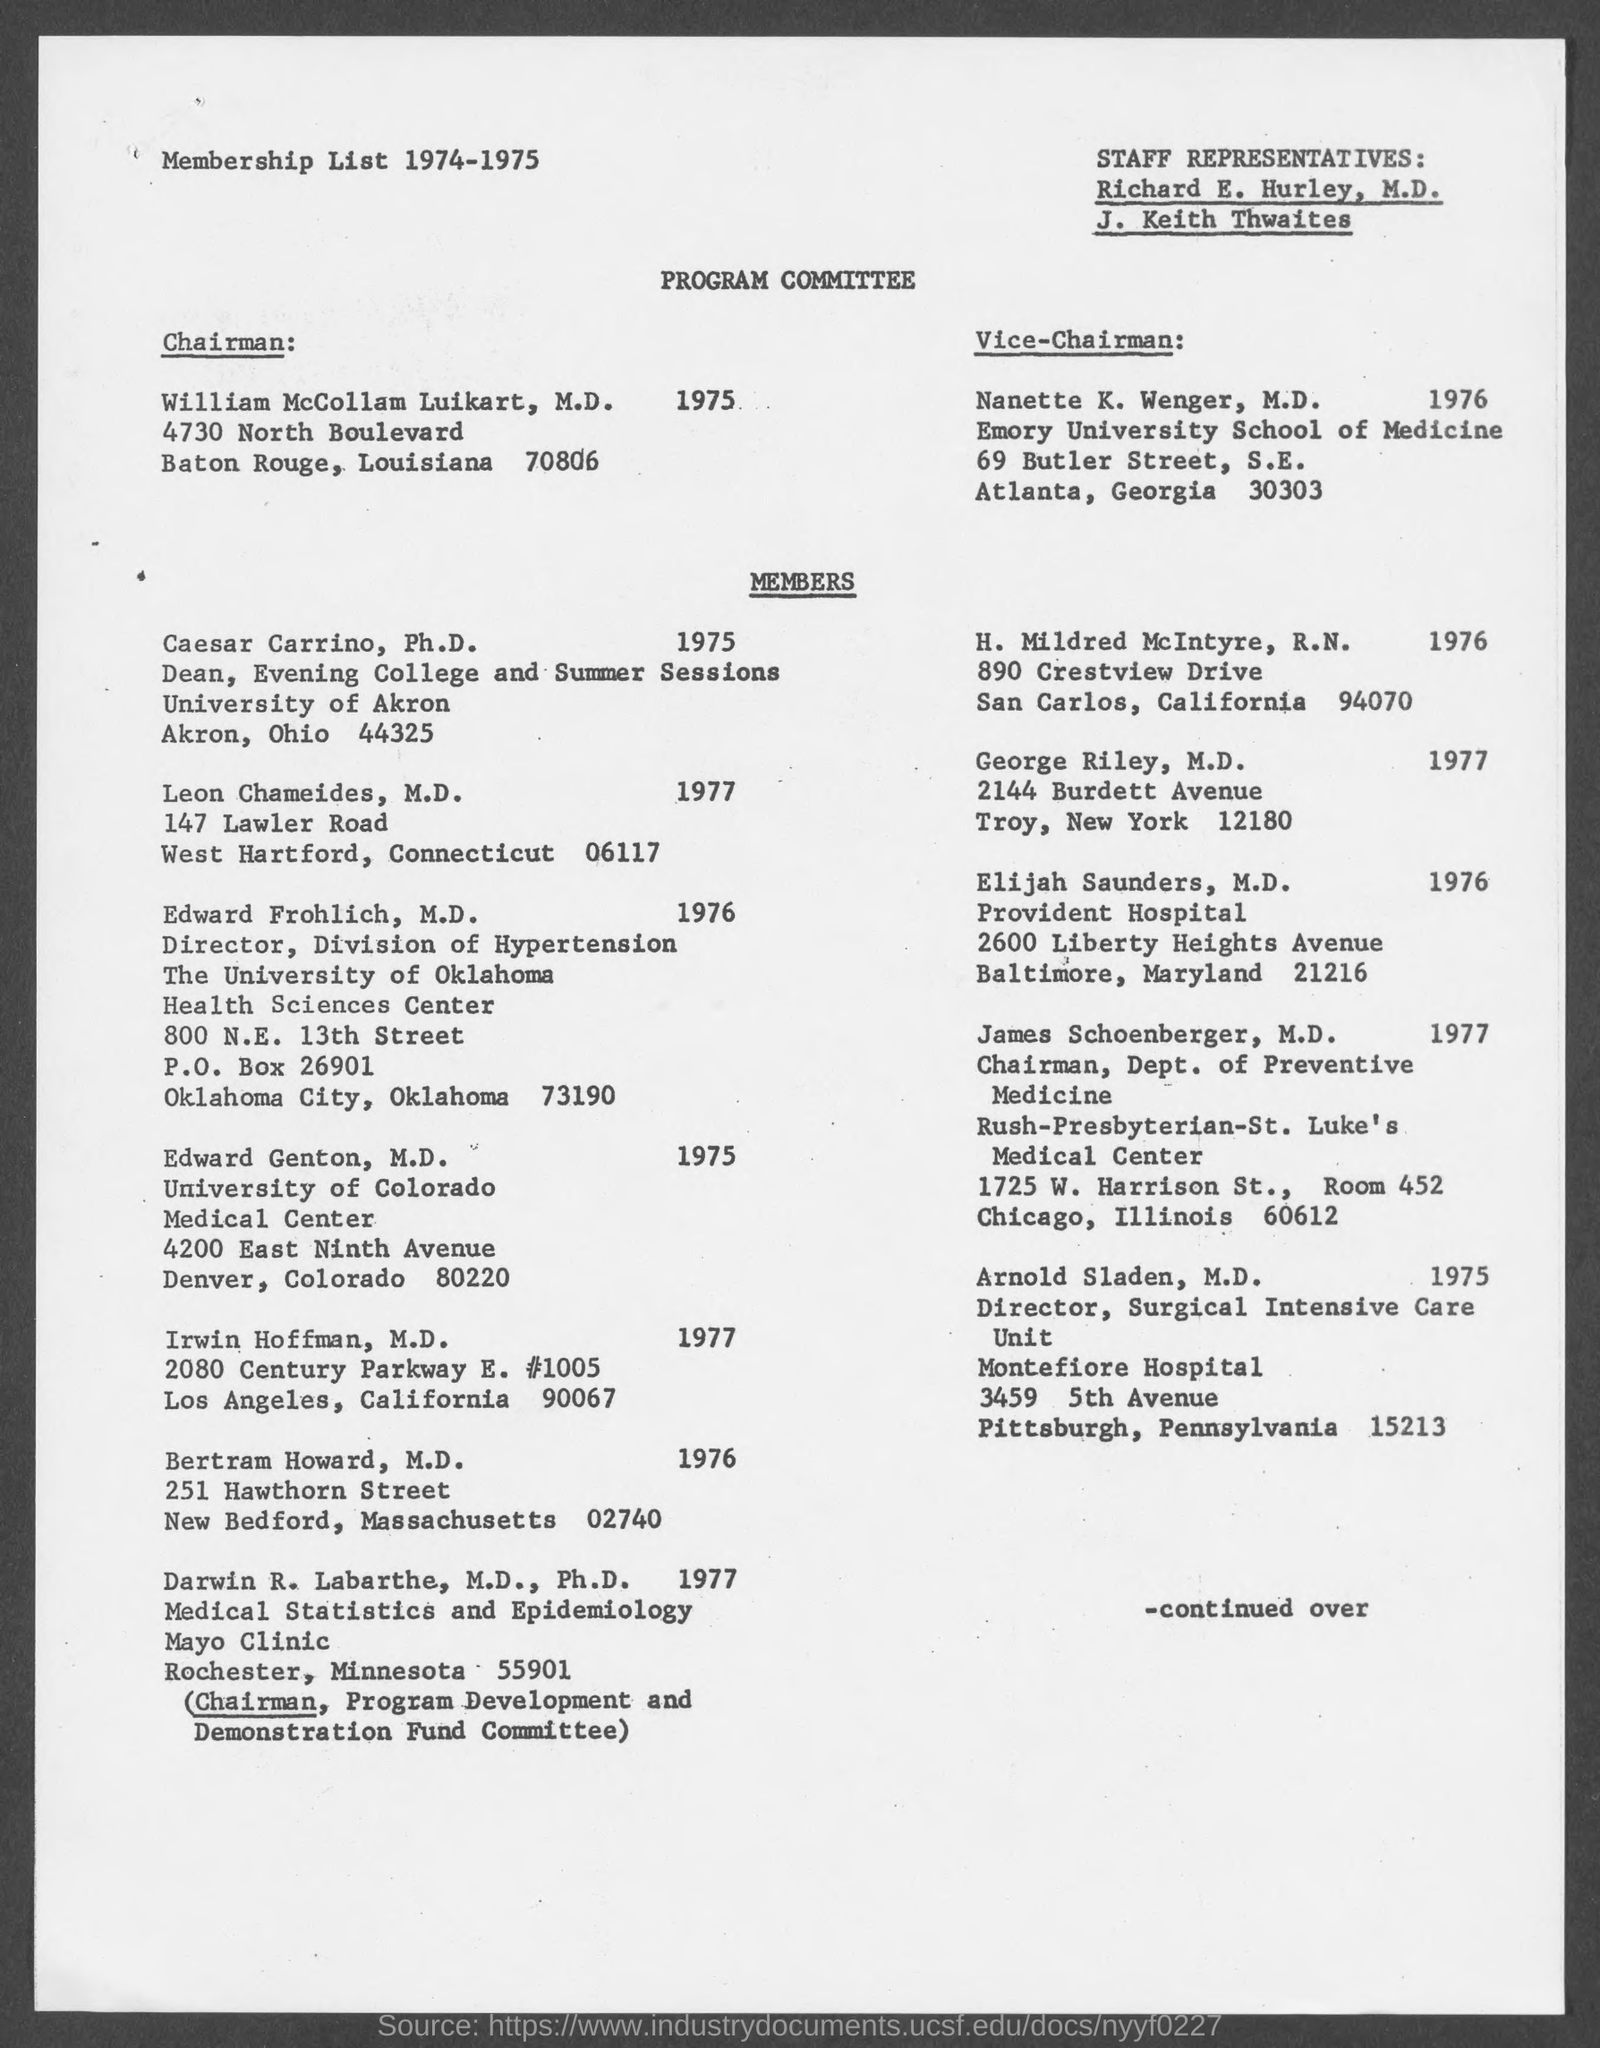Who is the chairman of program committee ?
Offer a very short reply. William McCollam Luikart. Who is the vice- chairman of program committee ?
Keep it short and to the point. Nanette K. Wenger, M.D. 